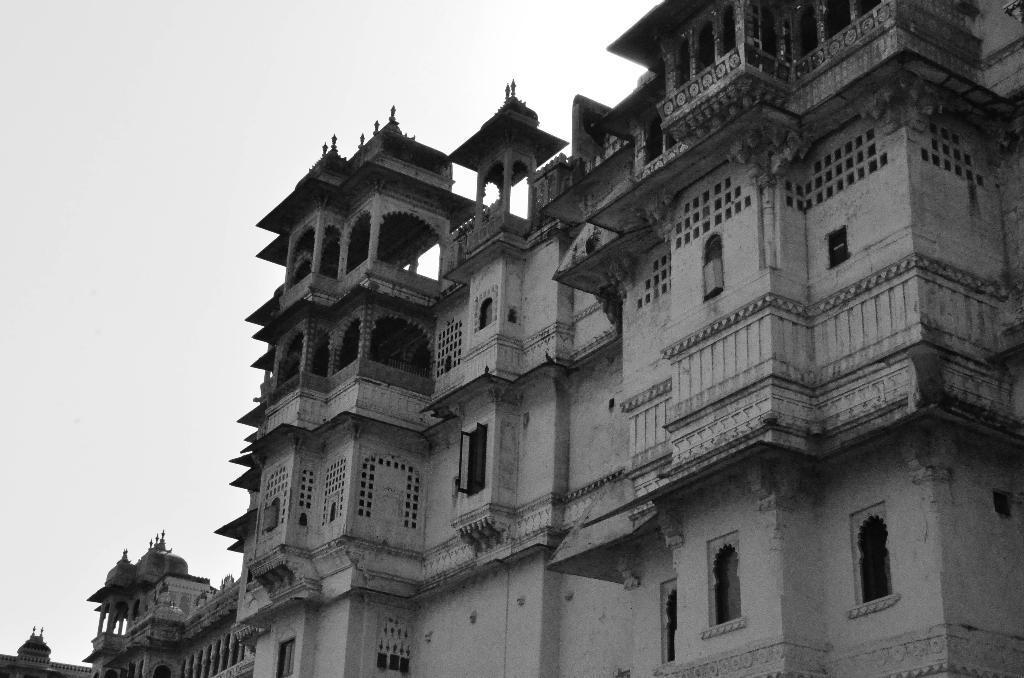What is the color scheme of the image? The image is black and white. What structure is located on the right side of the image? There is a building on the right side of the image. What feature can be seen on the building? The building has windows. What is visible at the top of the image? The sky is visible at the top of the image. Where are the scissors located in the image? There are no scissors present in the image. What type of straw is being used by the person in the image? There is no person or straw present in the image. 